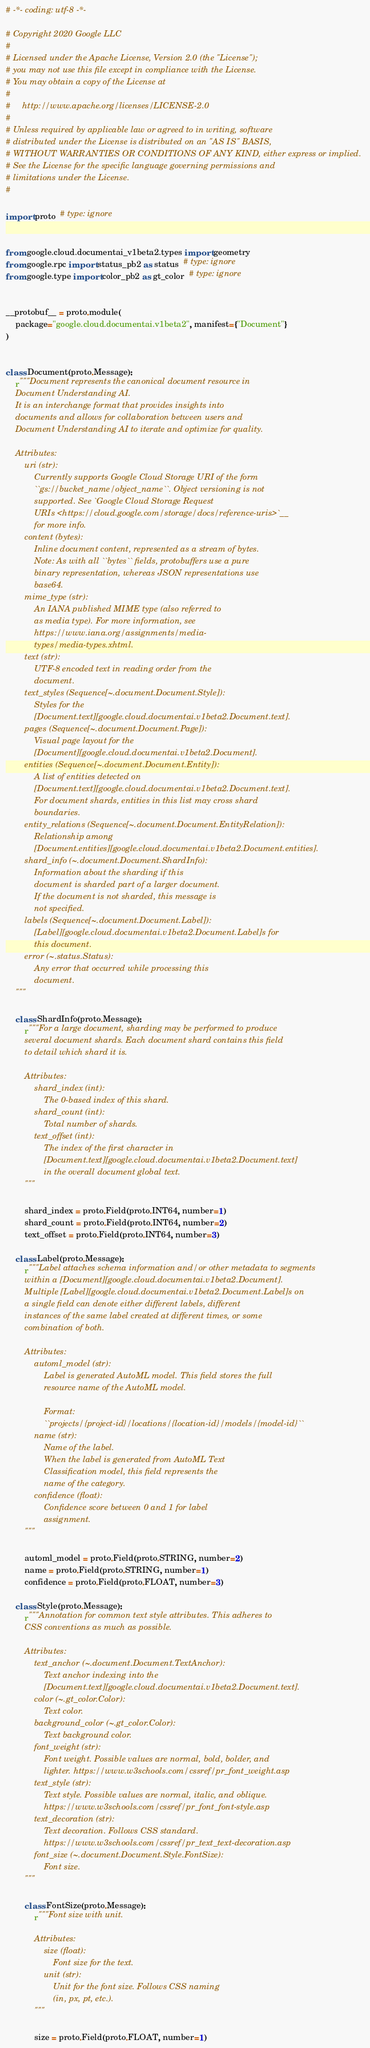Convert code to text. <code><loc_0><loc_0><loc_500><loc_500><_Python_># -*- coding: utf-8 -*-

# Copyright 2020 Google LLC
#
# Licensed under the Apache License, Version 2.0 (the "License");
# you may not use this file except in compliance with the License.
# You may obtain a copy of the License at
#
#     http://www.apache.org/licenses/LICENSE-2.0
#
# Unless required by applicable law or agreed to in writing, software
# distributed under the License is distributed on an "AS IS" BASIS,
# WITHOUT WARRANTIES OR CONDITIONS OF ANY KIND, either express or implied.
# See the License for the specific language governing permissions and
# limitations under the License.
#

import proto  # type: ignore


from google.cloud.documentai_v1beta2.types import geometry
from google.rpc import status_pb2 as status  # type: ignore
from google.type import color_pb2 as gt_color  # type: ignore


__protobuf__ = proto.module(
    package="google.cloud.documentai.v1beta2", manifest={"Document"}
)


class Document(proto.Message):
    r"""Document represents the canonical document resource in
    Document Understanding AI.
    It is an interchange format that provides insights into
    documents and allows for collaboration between users and
    Document Understanding AI to iterate and optimize for quality.

    Attributes:
        uri (str):
            Currently supports Google Cloud Storage URI of the form
            ``gs://bucket_name/object_name``. Object versioning is not
            supported. See `Google Cloud Storage Request
            URIs <https://cloud.google.com/storage/docs/reference-uris>`__
            for more info.
        content (bytes):
            Inline document content, represented as a stream of bytes.
            Note: As with all ``bytes`` fields, protobuffers use a pure
            binary representation, whereas JSON representations use
            base64.
        mime_type (str):
            An IANA published MIME type (also referred to
            as media type). For more information, see
            https://www.iana.org/assignments/media-
            types/media-types.xhtml.
        text (str):
            UTF-8 encoded text in reading order from the
            document.
        text_styles (Sequence[~.document.Document.Style]):
            Styles for the
            [Document.text][google.cloud.documentai.v1beta2.Document.text].
        pages (Sequence[~.document.Document.Page]):
            Visual page layout for the
            [Document][google.cloud.documentai.v1beta2.Document].
        entities (Sequence[~.document.Document.Entity]):
            A list of entities detected on
            [Document.text][google.cloud.documentai.v1beta2.Document.text].
            For document shards, entities in this list may cross shard
            boundaries.
        entity_relations (Sequence[~.document.Document.EntityRelation]):
            Relationship among
            [Document.entities][google.cloud.documentai.v1beta2.Document.entities].
        shard_info (~.document.Document.ShardInfo):
            Information about the sharding if this
            document is sharded part of a larger document.
            If the document is not sharded, this message is
            not specified.
        labels (Sequence[~.document.Document.Label]):
            [Label][google.cloud.documentai.v1beta2.Document.Label]s for
            this document.
        error (~.status.Status):
            Any error that occurred while processing this
            document.
    """

    class ShardInfo(proto.Message):
        r"""For a large document, sharding may be performed to produce
        several document shards. Each document shard contains this field
        to detail which shard it is.

        Attributes:
            shard_index (int):
                The 0-based index of this shard.
            shard_count (int):
                Total number of shards.
            text_offset (int):
                The index of the first character in
                [Document.text][google.cloud.documentai.v1beta2.Document.text]
                in the overall document global text.
        """

        shard_index = proto.Field(proto.INT64, number=1)
        shard_count = proto.Field(proto.INT64, number=2)
        text_offset = proto.Field(proto.INT64, number=3)

    class Label(proto.Message):
        r"""Label attaches schema information and/or other metadata to segments
        within a [Document][google.cloud.documentai.v1beta2.Document].
        Multiple [Label][google.cloud.documentai.v1beta2.Document.Label]s on
        a single field can denote either different labels, different
        instances of the same label created at different times, or some
        combination of both.

        Attributes:
            automl_model (str):
                Label is generated AutoML model. This field stores the full
                resource name of the AutoML model.

                Format:
                ``projects/{project-id}/locations/{location-id}/models/{model-id}``
            name (str):
                Name of the label.
                When the label is generated from AutoML Text
                Classification model, this field represents the
                name of the category.
            confidence (float):
                Confidence score between 0 and 1 for label
                assignment.
        """

        automl_model = proto.Field(proto.STRING, number=2)
        name = proto.Field(proto.STRING, number=1)
        confidence = proto.Field(proto.FLOAT, number=3)

    class Style(proto.Message):
        r"""Annotation for common text style attributes. This adheres to
        CSS conventions as much as possible.

        Attributes:
            text_anchor (~.document.Document.TextAnchor):
                Text anchor indexing into the
                [Document.text][google.cloud.documentai.v1beta2.Document.text].
            color (~.gt_color.Color):
                Text color.
            background_color (~.gt_color.Color):
                Text background color.
            font_weight (str):
                Font weight. Possible values are normal, bold, bolder, and
                lighter. https://www.w3schools.com/cssref/pr_font_weight.asp
            text_style (str):
                Text style. Possible values are normal, italic, and oblique.
                https://www.w3schools.com/cssref/pr_font_font-style.asp
            text_decoration (str):
                Text decoration. Follows CSS standard.
                https://www.w3schools.com/cssref/pr_text_text-decoration.asp
            font_size (~.document.Document.Style.FontSize):
                Font size.
        """

        class FontSize(proto.Message):
            r"""Font size with unit.

            Attributes:
                size (float):
                    Font size for the text.
                unit (str):
                    Unit for the font size. Follows CSS naming
                    (in, px, pt, etc.).
            """

            size = proto.Field(proto.FLOAT, number=1)</code> 